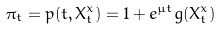Convert formula to latex. <formula><loc_0><loc_0><loc_500><loc_500>\pi _ { t } = p ( t , X ^ { x } _ { t } ) = 1 + e ^ { \mu t } g ( X ^ { x } _ { t } )</formula> 